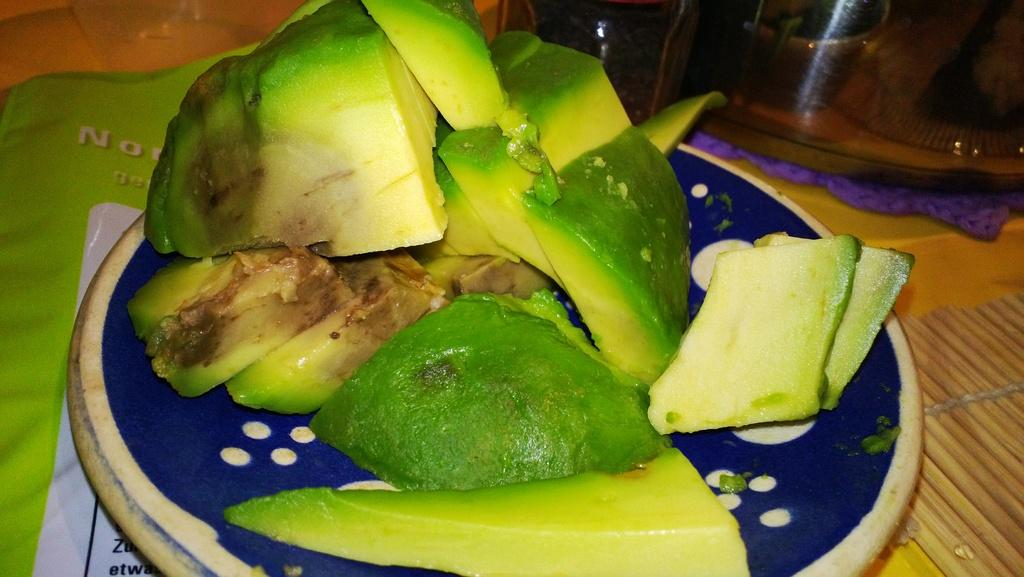What is the main subject of the image? The main subject of the image is a fruit cut into pieces. How is the fruit arranged in the image? The fruit is placed on a plate in the image. What is supporting the plate in the image? There is a table below the plate in the image. What type of guide is present in the image? There is no guide present in the image; it features a fruit cut into pieces on a plate, supported by a table. 